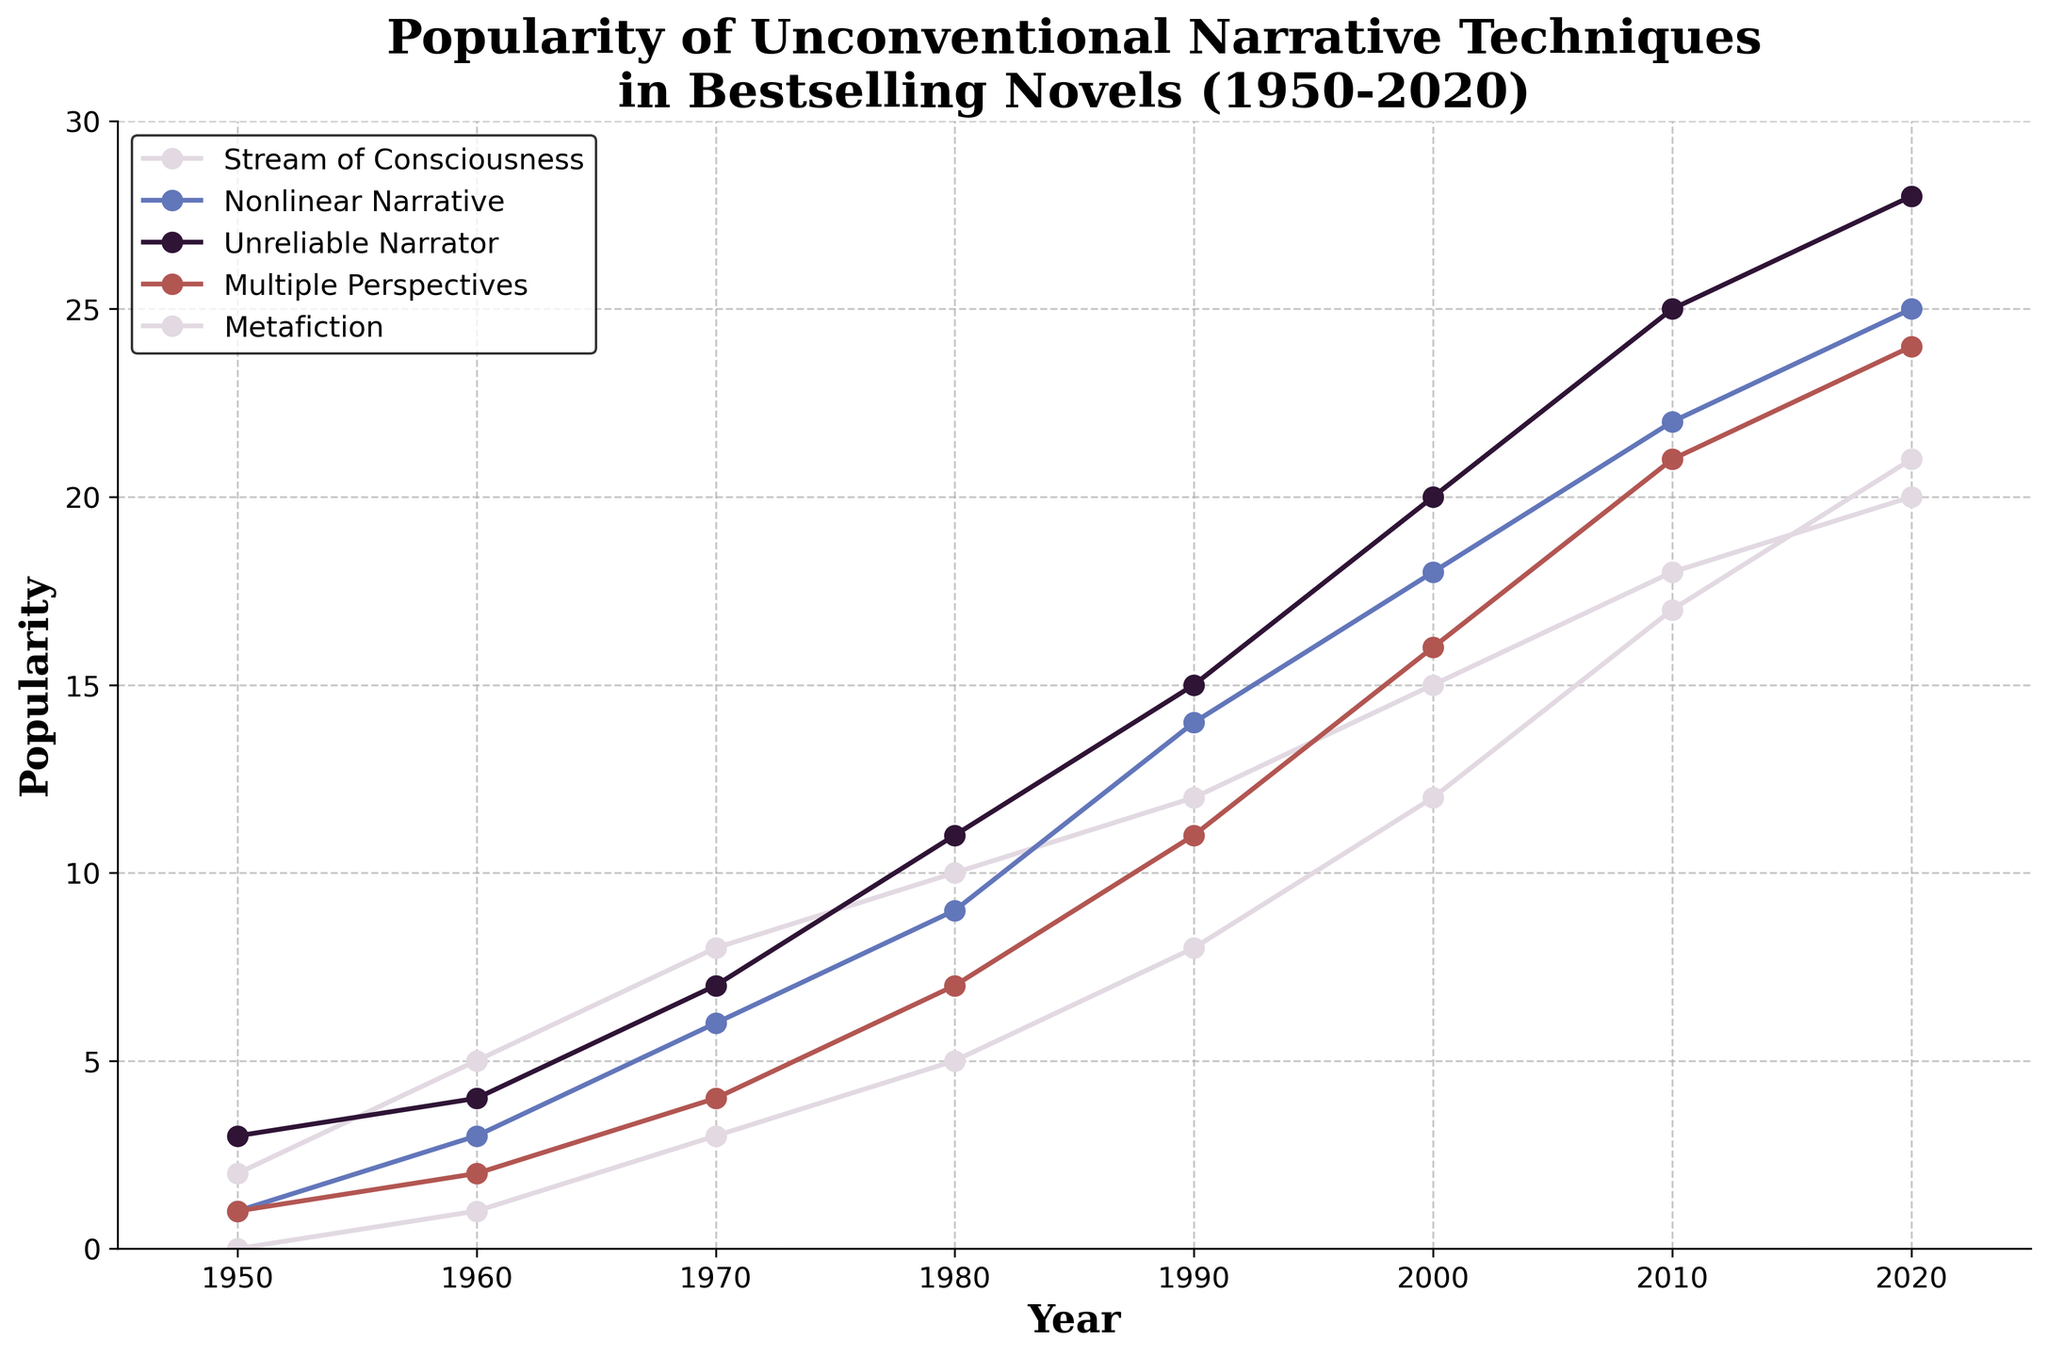What narrative technique observed the highest popularity in 2020? From the figure, in 2020, "Unreliable Narrator" has the highest point, reaching the top of the y-axis values among all narrative techniques.
Answer: Unreliable Narrator How did the popularity of 'Stream of Consciousness' change from 1950 to 2020? In 1950, 'Stream of Consciousness' was at 2. By 2020, it had increased to 20, which means there was a significant increase of 18 points over the period.
Answer: Increased by 18 points Between 1980 and 2000, which narrative technique showed the greatest increase in popularity? Looking at the slopes between 1980 and 2000, "Unreliable Narrator" increased from 11 to 20, an increase of 9, which is the largest among all techniques.
Answer: Unreliable Narrator In which decade did 'Metafiction' become more popular than 'Stream of Consciousness'? Observing the crossing points, 'Metafiction' surpasses 'Stream of Consciousness' between 2010 and 2020.
Answer: 2010-2020 What is the cumulative increase in popularity for 'Multiple Perspectives' from 1950 to 2020? 'Multiple Perspectives' started at 1 in 1950 and reached 24 in 2020. The cumulative increase is 24 - 1 = 23.
Answer: Increased by 23 points Which two narrative techniques had the most similar popularity trend from 1950 to 2020? By observing the closeness of the lines throughout the years, 'Stream of Consciousness' and 'Nonlinear Narrative' show more similar trends compared to others.
Answer: Stream of Consciousness and Nonlinear Narrative By 1970, what was the combined popularity of 'Nonlinear Narrative' and 'Unreliable Narrator'? In 1970, 'Nonlinear Narrative' is at 6 and 'Unreliable Narrator' is at 7. Their combined popularity is 6 + 7 = 13.
Answer: 13 Were there any years where 'Multiple Perspectives' had a lower popularity than 'Metafiction'? From the figure, 'Metafiction' consistently remains below 'Multiple Perspectives' in all years.
Answer: No In which decade did all narrative techniques show an increase in popularity without any exception? All lines on the graph increase continuously and without interruption from 1990 to 2000.
Answer: 1990-2000 